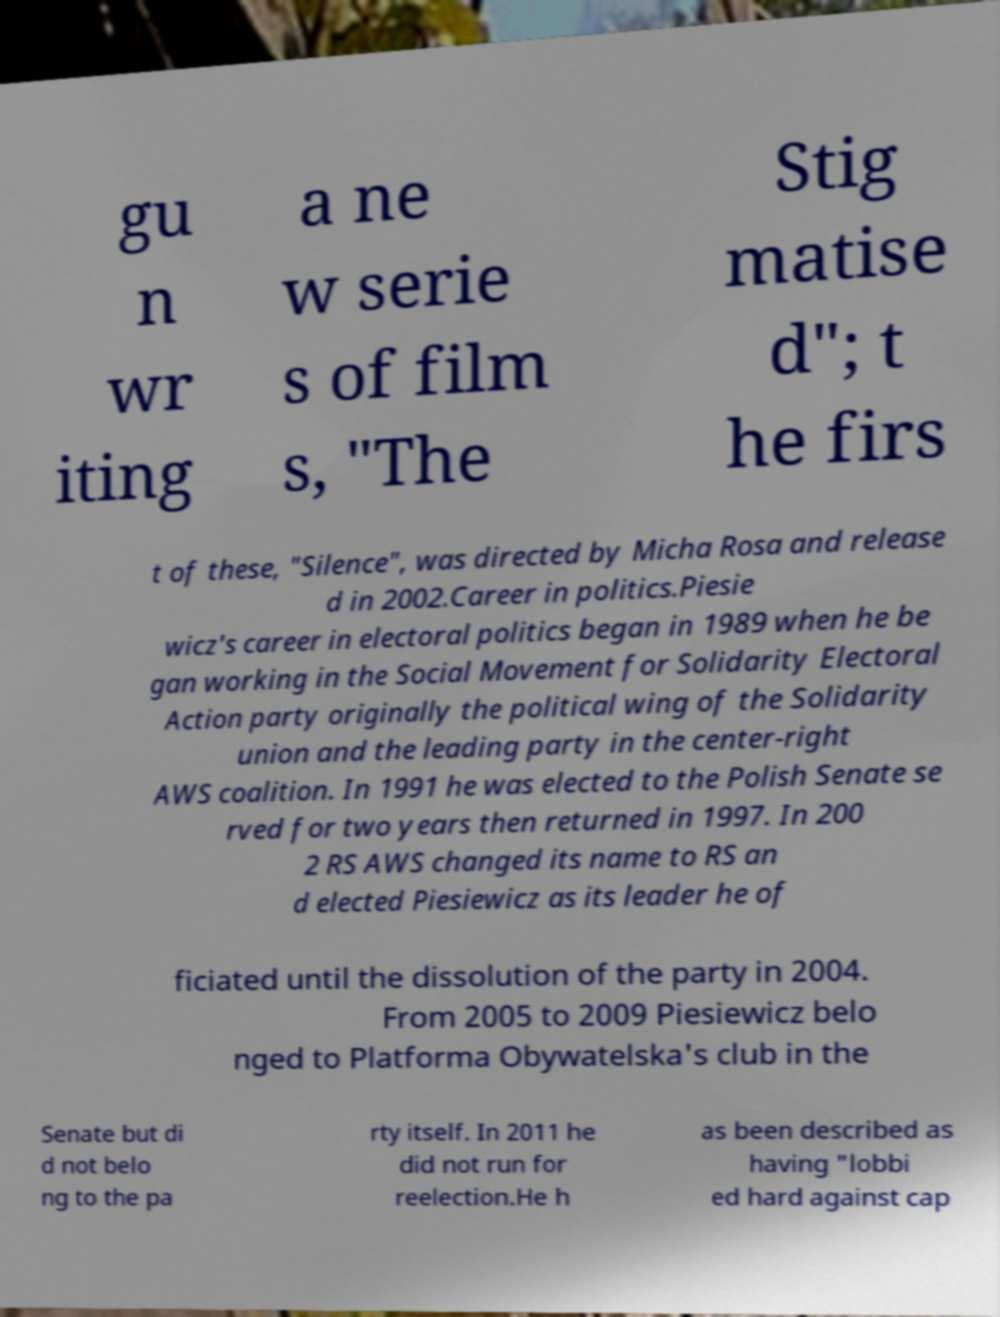There's text embedded in this image that I need extracted. Can you transcribe it verbatim? gu n wr iting a ne w serie s of film s, "The Stig matise d"; t he firs t of these, "Silence", was directed by Micha Rosa and release d in 2002.Career in politics.Piesie wicz's career in electoral politics began in 1989 when he be gan working in the Social Movement for Solidarity Electoral Action party originally the political wing of the Solidarity union and the leading party in the center-right AWS coalition. In 1991 he was elected to the Polish Senate se rved for two years then returned in 1997. In 200 2 RS AWS changed its name to RS an d elected Piesiewicz as its leader he of ficiated until the dissolution of the party in 2004. From 2005 to 2009 Piesiewicz belo nged to Platforma Obywatelska's club in the Senate but di d not belo ng to the pa rty itself. In 2011 he did not run for reelection.He h as been described as having "lobbi ed hard against cap 